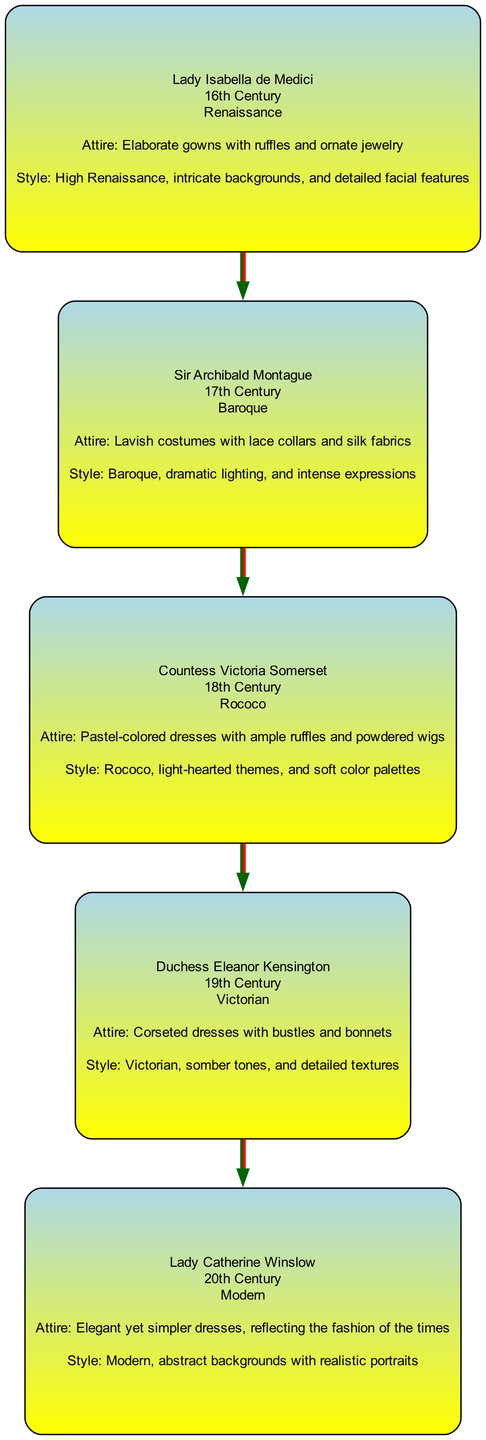What is the name of the first family member depicted? The first family member is listed under Generation 1 and is named Lady Isabella de Medici. This can be found by looking at the first node in the diagram.
Answer: Lady Isabella de Medici How many generations are represented in the family tree? The diagram contains five generations, as indicated by the different sections for each Generation 1 through 5.
Answer: 5 Which artistic style is associated with Countess Victoria Somerset? By looking at the node corresponding to Countess Victoria Somerset in Generation 3, it states that her artistic style is Rococo.
Answer: Rococo What is the attire of Duchess Eleanor Kensington? The attire for Duchess Eleanor Kensington is detailed in her node and it is described as "Corseted dresses with bustles and bonnets." This is directly found in her corresponding section.
Answer: Corseted dresses with bustles and bonnets Which period does Lady Catherine Winslow belong to? To answer this, one would refer to Lady Catherine's node in Generation 5, where it specifically identifies her associated period as Modern.
Answer: Modern Name the family member from the Baroque period. The member noted for the Baroque period in Generation 2 is Sir Archibald Montague. This information can be located within the Generation 2 section of the diagram.
Answer: Sir Archibald Montague What is the relationship between Lady Isabella de Medici and Sir Archibald Montague? The diagram indicates that Lady Isabella de Medici is from Generation 1, while Sir Archibald Montague is from Generation 2. Since they are in consecutive generations, Lady Isabella is the mother of Sir Archibald.
Answer: Mother Which generation features pastel-colored dresses? This detail is found in Generation 3, where Countess Victoria Somerset's attire is described as "Pastel-colored dresses with ample ruffles and powdered wigs." Therefore, Generation 3 is where pastel colors are mentioned.
Answer: Generation 3 What distinguishing characteristic is mentioned about the artistic style of Duchess Eleanor Kensington? The artistic style for Duchess Eleanor Kensington is described in her node as being Victorian, noted for its somber tones and detailed textures. This can be found by inspecting her section in the diagram.
Answer: Somber tones and detailed textures 